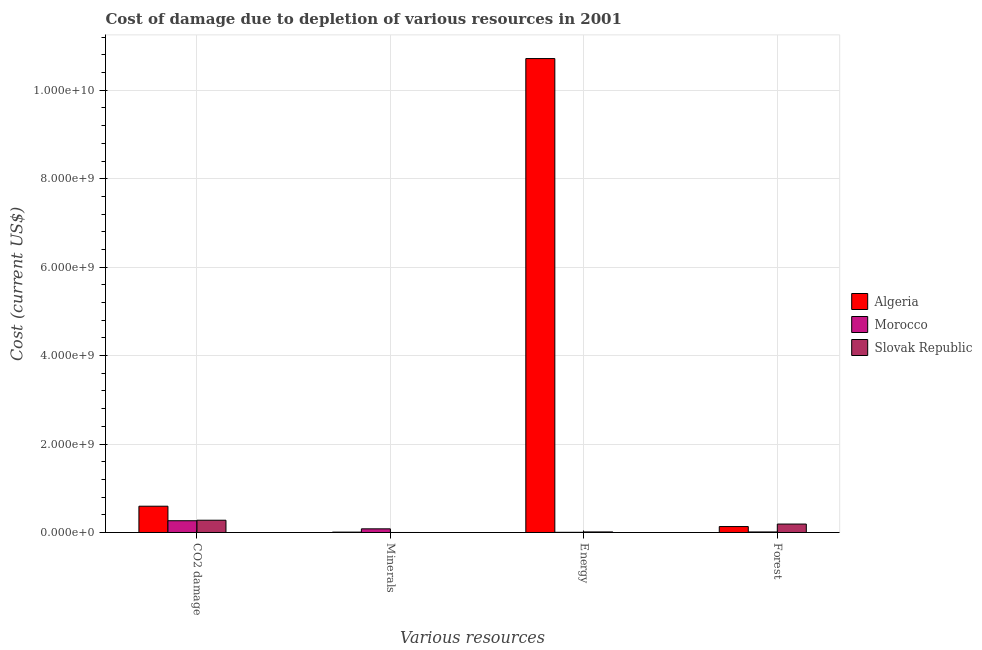How many groups of bars are there?
Your answer should be compact. 4. Are the number of bars per tick equal to the number of legend labels?
Keep it short and to the point. Yes. Are the number of bars on each tick of the X-axis equal?
Offer a very short reply. Yes. How many bars are there on the 4th tick from the left?
Your answer should be compact. 3. How many bars are there on the 3rd tick from the right?
Offer a very short reply. 3. What is the label of the 2nd group of bars from the left?
Offer a very short reply. Minerals. What is the cost of damage due to depletion of forests in Algeria?
Give a very brief answer. 1.34e+08. Across all countries, what is the maximum cost of damage due to depletion of energy?
Keep it short and to the point. 1.07e+1. Across all countries, what is the minimum cost of damage due to depletion of forests?
Provide a short and direct response. 1.21e+07. In which country was the cost of damage due to depletion of minerals maximum?
Your response must be concise. Morocco. In which country was the cost of damage due to depletion of energy minimum?
Make the answer very short. Morocco. What is the total cost of damage due to depletion of forests in the graph?
Your answer should be compact. 3.37e+08. What is the difference between the cost of damage due to depletion of minerals in Algeria and that in Morocco?
Give a very brief answer. -7.44e+07. What is the difference between the cost of damage due to depletion of energy in Algeria and the cost of damage due to depletion of minerals in Slovak Republic?
Give a very brief answer. 1.07e+1. What is the average cost of damage due to depletion of forests per country?
Provide a short and direct response. 1.12e+08. What is the difference between the cost of damage due to depletion of forests and cost of damage due to depletion of coal in Morocco?
Keep it short and to the point. -2.54e+08. What is the ratio of the cost of damage due to depletion of coal in Morocco to that in Algeria?
Offer a very short reply. 0.45. Is the cost of damage due to depletion of coal in Algeria less than that in Morocco?
Your answer should be very brief. No. Is the difference between the cost of damage due to depletion of minerals in Morocco and Slovak Republic greater than the difference between the cost of damage due to depletion of energy in Morocco and Slovak Republic?
Keep it short and to the point. Yes. What is the difference between the highest and the second highest cost of damage due to depletion of energy?
Provide a succinct answer. 1.07e+1. What is the difference between the highest and the lowest cost of damage due to depletion of energy?
Ensure brevity in your answer.  1.07e+1. Is the sum of the cost of damage due to depletion of forests in Morocco and Algeria greater than the maximum cost of damage due to depletion of coal across all countries?
Offer a very short reply. No. Is it the case that in every country, the sum of the cost of damage due to depletion of forests and cost of damage due to depletion of minerals is greater than the sum of cost of damage due to depletion of energy and cost of damage due to depletion of coal?
Offer a very short reply. Yes. What does the 2nd bar from the left in Forest represents?
Ensure brevity in your answer.  Morocco. What does the 2nd bar from the right in Energy represents?
Keep it short and to the point. Morocco. Are all the bars in the graph horizontal?
Offer a very short reply. No. Are the values on the major ticks of Y-axis written in scientific E-notation?
Give a very brief answer. Yes. Does the graph contain grids?
Make the answer very short. Yes. Where does the legend appear in the graph?
Provide a succinct answer. Center right. How are the legend labels stacked?
Your answer should be compact. Vertical. What is the title of the graph?
Keep it short and to the point. Cost of damage due to depletion of various resources in 2001 . Does "Guinea-Bissau" appear as one of the legend labels in the graph?
Ensure brevity in your answer.  No. What is the label or title of the X-axis?
Provide a short and direct response. Various resources. What is the label or title of the Y-axis?
Your response must be concise. Cost (current US$). What is the Cost (current US$) of Algeria in CO2 damage?
Provide a succinct answer. 5.94e+08. What is the Cost (current US$) of Morocco in CO2 damage?
Give a very brief answer. 2.66e+08. What is the Cost (current US$) of Slovak Republic in CO2 damage?
Provide a short and direct response. 2.77e+08. What is the Cost (current US$) of Algeria in Minerals?
Provide a short and direct response. 8.20e+06. What is the Cost (current US$) in Morocco in Minerals?
Your answer should be compact. 8.26e+07. What is the Cost (current US$) in Slovak Republic in Minerals?
Give a very brief answer. 1.99e+04. What is the Cost (current US$) in Algeria in Energy?
Offer a terse response. 1.07e+1. What is the Cost (current US$) of Morocco in Energy?
Offer a terse response. 4.21e+06. What is the Cost (current US$) of Slovak Republic in Energy?
Offer a terse response. 1.26e+07. What is the Cost (current US$) of Algeria in Forest?
Provide a succinct answer. 1.34e+08. What is the Cost (current US$) in Morocco in Forest?
Ensure brevity in your answer.  1.21e+07. What is the Cost (current US$) of Slovak Republic in Forest?
Your response must be concise. 1.91e+08. Across all Various resources, what is the maximum Cost (current US$) of Algeria?
Give a very brief answer. 1.07e+1. Across all Various resources, what is the maximum Cost (current US$) in Morocco?
Your response must be concise. 2.66e+08. Across all Various resources, what is the maximum Cost (current US$) in Slovak Republic?
Ensure brevity in your answer.  2.77e+08. Across all Various resources, what is the minimum Cost (current US$) in Algeria?
Offer a very short reply. 8.20e+06. Across all Various resources, what is the minimum Cost (current US$) of Morocco?
Your answer should be very brief. 4.21e+06. Across all Various resources, what is the minimum Cost (current US$) in Slovak Republic?
Your response must be concise. 1.99e+04. What is the total Cost (current US$) of Algeria in the graph?
Keep it short and to the point. 1.15e+1. What is the total Cost (current US$) of Morocco in the graph?
Provide a succinct answer. 3.65e+08. What is the total Cost (current US$) in Slovak Republic in the graph?
Offer a terse response. 4.81e+08. What is the difference between the Cost (current US$) of Algeria in CO2 damage and that in Minerals?
Keep it short and to the point. 5.86e+08. What is the difference between the Cost (current US$) in Morocco in CO2 damage and that in Minerals?
Provide a succinct answer. 1.83e+08. What is the difference between the Cost (current US$) in Slovak Republic in CO2 damage and that in Minerals?
Make the answer very short. 2.77e+08. What is the difference between the Cost (current US$) in Algeria in CO2 damage and that in Energy?
Ensure brevity in your answer.  -1.01e+1. What is the difference between the Cost (current US$) in Morocco in CO2 damage and that in Energy?
Ensure brevity in your answer.  2.62e+08. What is the difference between the Cost (current US$) in Slovak Republic in CO2 damage and that in Energy?
Offer a very short reply. 2.65e+08. What is the difference between the Cost (current US$) of Algeria in CO2 damage and that in Forest?
Make the answer very short. 4.60e+08. What is the difference between the Cost (current US$) of Morocco in CO2 damage and that in Forest?
Provide a succinct answer. 2.54e+08. What is the difference between the Cost (current US$) in Slovak Republic in CO2 damage and that in Forest?
Provide a succinct answer. 8.66e+07. What is the difference between the Cost (current US$) in Algeria in Minerals and that in Energy?
Ensure brevity in your answer.  -1.07e+1. What is the difference between the Cost (current US$) in Morocco in Minerals and that in Energy?
Offer a terse response. 7.84e+07. What is the difference between the Cost (current US$) in Slovak Republic in Minerals and that in Energy?
Your answer should be very brief. -1.26e+07. What is the difference between the Cost (current US$) in Algeria in Minerals and that in Forest?
Your answer should be compact. -1.26e+08. What is the difference between the Cost (current US$) in Morocco in Minerals and that in Forest?
Give a very brief answer. 7.05e+07. What is the difference between the Cost (current US$) of Slovak Republic in Minerals and that in Forest?
Offer a very short reply. -1.91e+08. What is the difference between the Cost (current US$) in Algeria in Energy and that in Forest?
Provide a short and direct response. 1.06e+1. What is the difference between the Cost (current US$) of Morocco in Energy and that in Forest?
Your response must be concise. -7.87e+06. What is the difference between the Cost (current US$) in Slovak Republic in Energy and that in Forest?
Provide a short and direct response. -1.78e+08. What is the difference between the Cost (current US$) of Algeria in CO2 damage and the Cost (current US$) of Morocco in Minerals?
Provide a short and direct response. 5.12e+08. What is the difference between the Cost (current US$) of Algeria in CO2 damage and the Cost (current US$) of Slovak Republic in Minerals?
Offer a very short reply. 5.94e+08. What is the difference between the Cost (current US$) in Morocco in CO2 damage and the Cost (current US$) in Slovak Republic in Minerals?
Offer a very short reply. 2.66e+08. What is the difference between the Cost (current US$) of Algeria in CO2 damage and the Cost (current US$) of Morocco in Energy?
Your answer should be compact. 5.90e+08. What is the difference between the Cost (current US$) in Algeria in CO2 damage and the Cost (current US$) in Slovak Republic in Energy?
Provide a succinct answer. 5.81e+08. What is the difference between the Cost (current US$) of Morocco in CO2 damage and the Cost (current US$) of Slovak Republic in Energy?
Your response must be concise. 2.53e+08. What is the difference between the Cost (current US$) of Algeria in CO2 damage and the Cost (current US$) of Morocco in Forest?
Your response must be concise. 5.82e+08. What is the difference between the Cost (current US$) of Algeria in CO2 damage and the Cost (current US$) of Slovak Republic in Forest?
Offer a very short reply. 4.03e+08. What is the difference between the Cost (current US$) of Morocco in CO2 damage and the Cost (current US$) of Slovak Republic in Forest?
Your answer should be very brief. 7.51e+07. What is the difference between the Cost (current US$) in Algeria in Minerals and the Cost (current US$) in Morocco in Energy?
Offer a very short reply. 3.99e+06. What is the difference between the Cost (current US$) of Algeria in Minerals and the Cost (current US$) of Slovak Republic in Energy?
Your response must be concise. -4.41e+06. What is the difference between the Cost (current US$) of Morocco in Minerals and the Cost (current US$) of Slovak Republic in Energy?
Provide a succinct answer. 7.00e+07. What is the difference between the Cost (current US$) of Algeria in Minerals and the Cost (current US$) of Morocco in Forest?
Make the answer very short. -3.89e+06. What is the difference between the Cost (current US$) in Algeria in Minerals and the Cost (current US$) in Slovak Republic in Forest?
Your answer should be very brief. -1.83e+08. What is the difference between the Cost (current US$) in Morocco in Minerals and the Cost (current US$) in Slovak Republic in Forest?
Keep it short and to the point. -1.08e+08. What is the difference between the Cost (current US$) in Algeria in Energy and the Cost (current US$) in Morocco in Forest?
Make the answer very short. 1.07e+1. What is the difference between the Cost (current US$) of Algeria in Energy and the Cost (current US$) of Slovak Republic in Forest?
Offer a terse response. 1.05e+1. What is the difference between the Cost (current US$) in Morocco in Energy and the Cost (current US$) in Slovak Republic in Forest?
Your answer should be compact. -1.87e+08. What is the average Cost (current US$) in Algeria per Various resources?
Make the answer very short. 2.86e+09. What is the average Cost (current US$) of Morocco per Various resources?
Keep it short and to the point. 9.12e+07. What is the average Cost (current US$) in Slovak Republic per Various resources?
Offer a very short reply. 1.20e+08. What is the difference between the Cost (current US$) of Algeria and Cost (current US$) of Morocco in CO2 damage?
Your response must be concise. 3.28e+08. What is the difference between the Cost (current US$) in Algeria and Cost (current US$) in Slovak Republic in CO2 damage?
Provide a succinct answer. 3.17e+08. What is the difference between the Cost (current US$) of Morocco and Cost (current US$) of Slovak Republic in CO2 damage?
Your answer should be very brief. -1.16e+07. What is the difference between the Cost (current US$) of Algeria and Cost (current US$) of Morocco in Minerals?
Keep it short and to the point. -7.44e+07. What is the difference between the Cost (current US$) in Algeria and Cost (current US$) in Slovak Republic in Minerals?
Give a very brief answer. 8.18e+06. What is the difference between the Cost (current US$) of Morocco and Cost (current US$) of Slovak Republic in Minerals?
Provide a short and direct response. 8.26e+07. What is the difference between the Cost (current US$) of Algeria and Cost (current US$) of Morocco in Energy?
Provide a short and direct response. 1.07e+1. What is the difference between the Cost (current US$) of Algeria and Cost (current US$) of Slovak Republic in Energy?
Ensure brevity in your answer.  1.07e+1. What is the difference between the Cost (current US$) of Morocco and Cost (current US$) of Slovak Republic in Energy?
Make the answer very short. -8.40e+06. What is the difference between the Cost (current US$) of Algeria and Cost (current US$) of Morocco in Forest?
Provide a succinct answer. 1.22e+08. What is the difference between the Cost (current US$) in Algeria and Cost (current US$) in Slovak Republic in Forest?
Your answer should be very brief. -5.66e+07. What is the difference between the Cost (current US$) in Morocco and Cost (current US$) in Slovak Republic in Forest?
Your response must be concise. -1.79e+08. What is the ratio of the Cost (current US$) of Algeria in CO2 damage to that in Minerals?
Ensure brevity in your answer.  72.49. What is the ratio of the Cost (current US$) of Morocco in CO2 damage to that in Minerals?
Your answer should be compact. 3.22. What is the ratio of the Cost (current US$) of Slovak Republic in CO2 damage to that in Minerals?
Offer a very short reply. 1.39e+04. What is the ratio of the Cost (current US$) of Algeria in CO2 damage to that in Energy?
Provide a succinct answer. 0.06. What is the ratio of the Cost (current US$) in Morocco in CO2 damage to that in Energy?
Keep it short and to the point. 63.16. What is the ratio of the Cost (current US$) of Slovak Republic in CO2 damage to that in Energy?
Make the answer very short. 22. What is the ratio of the Cost (current US$) of Algeria in CO2 damage to that in Forest?
Ensure brevity in your answer.  4.43. What is the ratio of the Cost (current US$) in Morocco in CO2 damage to that in Forest?
Your answer should be very brief. 22. What is the ratio of the Cost (current US$) of Slovak Republic in CO2 damage to that in Forest?
Your answer should be very brief. 1.45. What is the ratio of the Cost (current US$) of Algeria in Minerals to that in Energy?
Give a very brief answer. 0. What is the ratio of the Cost (current US$) in Morocco in Minerals to that in Energy?
Keep it short and to the point. 19.62. What is the ratio of the Cost (current US$) of Slovak Republic in Minerals to that in Energy?
Give a very brief answer. 0. What is the ratio of the Cost (current US$) in Algeria in Minerals to that in Forest?
Make the answer very short. 0.06. What is the ratio of the Cost (current US$) in Morocco in Minerals to that in Forest?
Your response must be concise. 6.83. What is the ratio of the Cost (current US$) in Slovak Republic in Minerals to that in Forest?
Your answer should be compact. 0. What is the ratio of the Cost (current US$) of Algeria in Energy to that in Forest?
Make the answer very short. 79.92. What is the ratio of the Cost (current US$) in Morocco in Energy to that in Forest?
Your answer should be compact. 0.35. What is the ratio of the Cost (current US$) of Slovak Republic in Energy to that in Forest?
Your response must be concise. 0.07. What is the difference between the highest and the second highest Cost (current US$) of Algeria?
Provide a succinct answer. 1.01e+1. What is the difference between the highest and the second highest Cost (current US$) of Morocco?
Keep it short and to the point. 1.83e+08. What is the difference between the highest and the second highest Cost (current US$) of Slovak Republic?
Offer a terse response. 8.66e+07. What is the difference between the highest and the lowest Cost (current US$) of Algeria?
Make the answer very short. 1.07e+1. What is the difference between the highest and the lowest Cost (current US$) in Morocco?
Make the answer very short. 2.62e+08. What is the difference between the highest and the lowest Cost (current US$) of Slovak Republic?
Make the answer very short. 2.77e+08. 